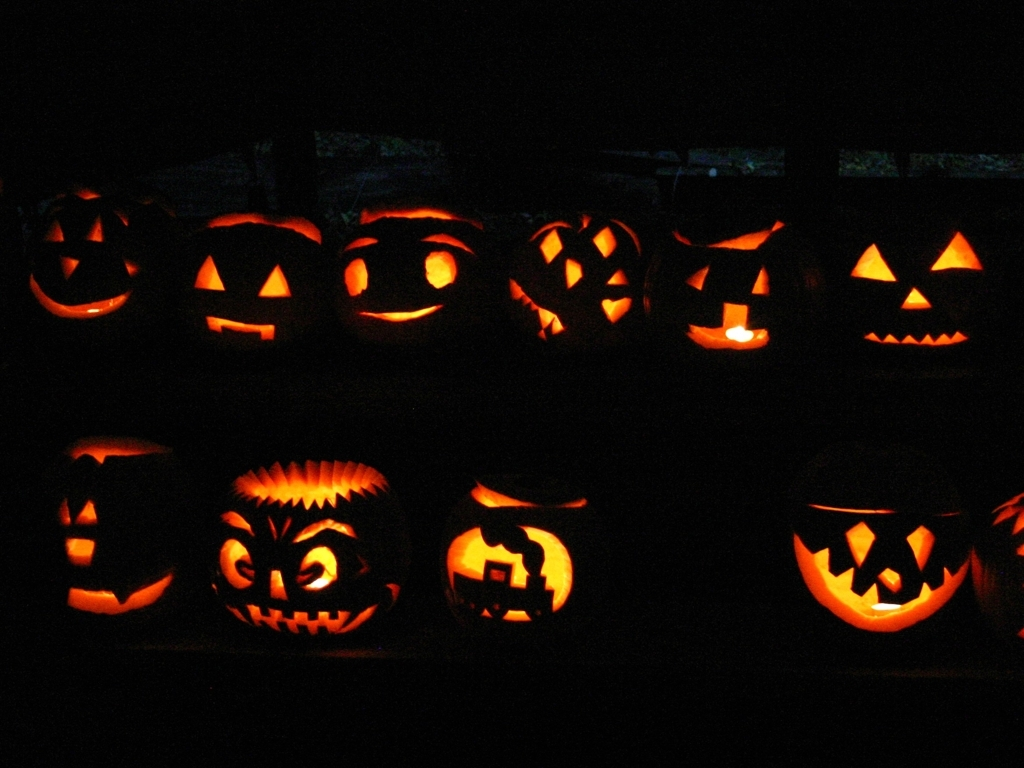Can you describe the expressions on the pumpkins? Certainly, the pumpkins have a variety of expressions. Some display traditional spooky grins, while others have more intricate designs that resemble menacing or whimsical faces. Each pumpkin has its unique character, contributing to a festive Halloween atmosphere. 